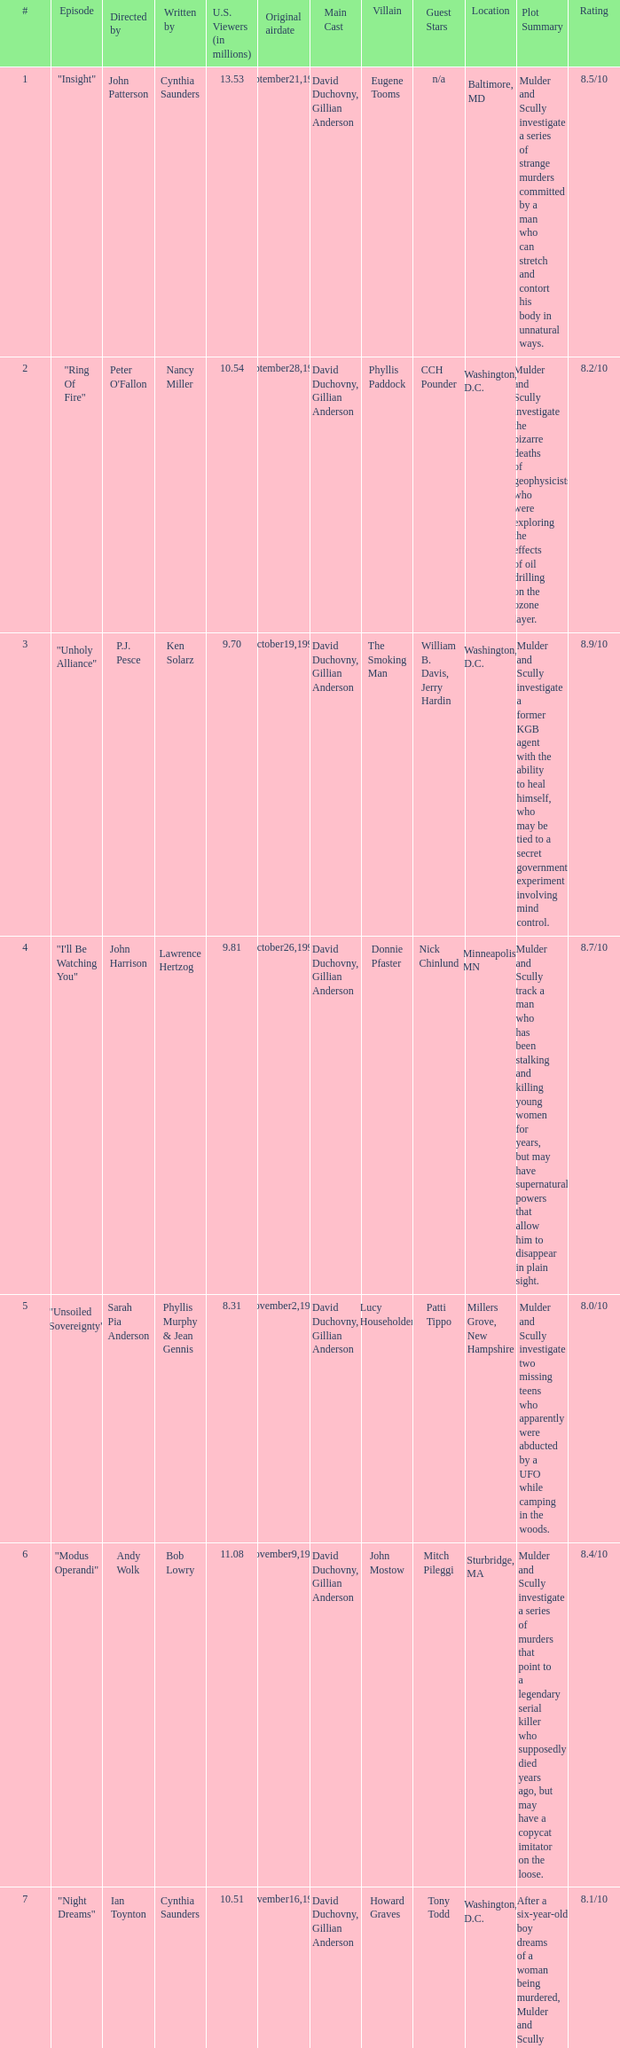What are the titles of episodes numbered 19? "FTX: Field Training Exercise". 